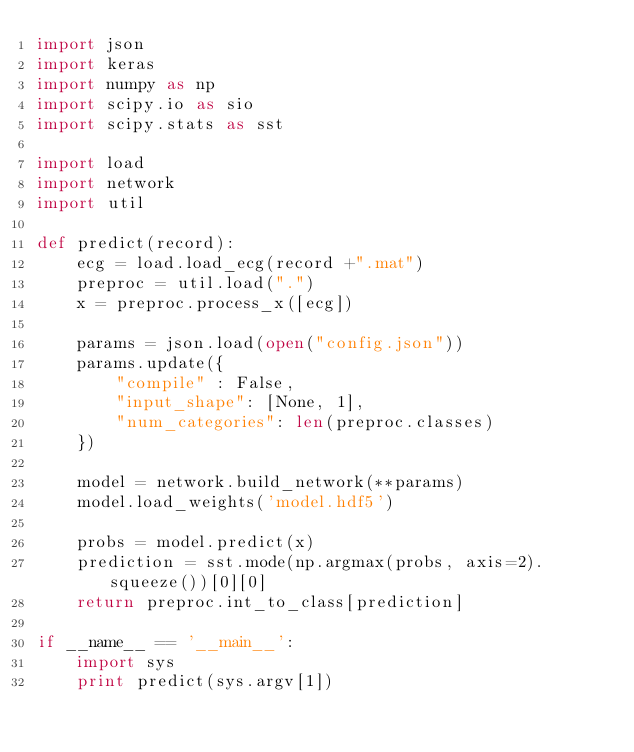Convert code to text. <code><loc_0><loc_0><loc_500><loc_500><_Python_>import json
import keras
import numpy as np
import scipy.io as sio
import scipy.stats as sst

import load
import network
import util

def predict(record):
    ecg = load.load_ecg(record +".mat")
    preproc = util.load(".")
    x = preproc.process_x([ecg])

    params = json.load(open("config.json"))
    params.update({
        "compile" : False,
        "input_shape": [None, 1],
        "num_categories": len(preproc.classes)
    })

    model = network.build_network(**params)
    model.load_weights('model.hdf5')

    probs = model.predict(x)
    prediction = sst.mode(np.argmax(probs, axis=2).squeeze())[0][0]
    return preproc.int_to_class[prediction]

if __name__ == '__main__':
    import sys
    print predict(sys.argv[1])
</code> 